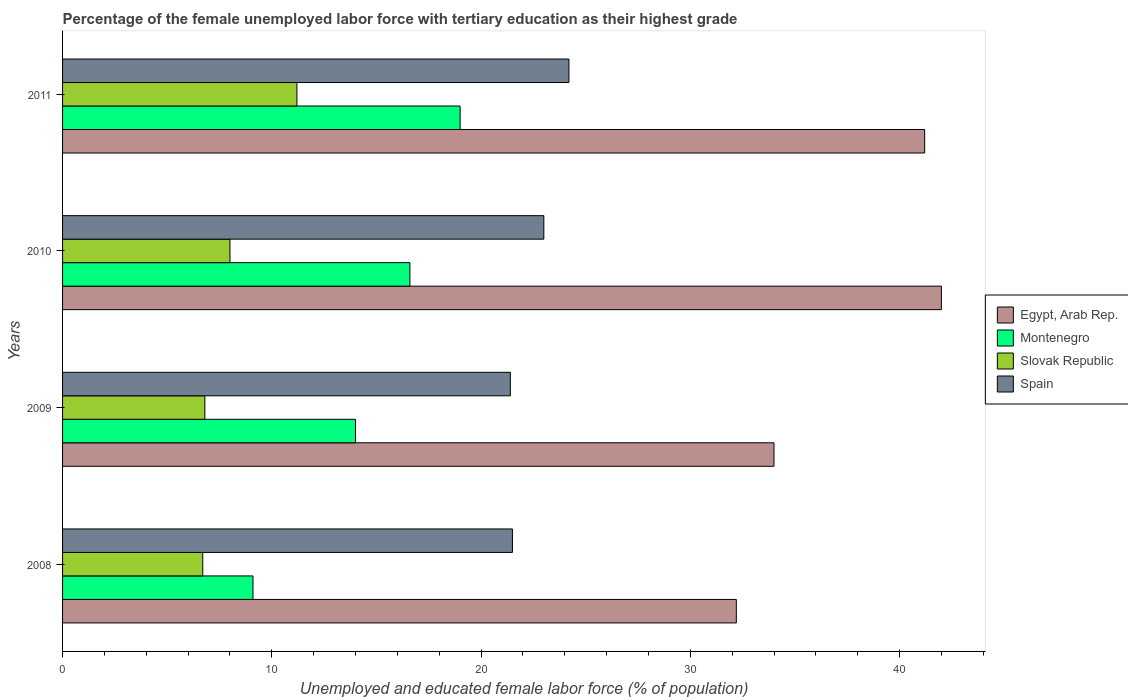How many different coloured bars are there?
Provide a short and direct response. 4. How many groups of bars are there?
Ensure brevity in your answer.  4. Are the number of bars per tick equal to the number of legend labels?
Keep it short and to the point. Yes. Are the number of bars on each tick of the Y-axis equal?
Provide a succinct answer. Yes. How many bars are there on the 3rd tick from the top?
Make the answer very short. 4. What is the label of the 2nd group of bars from the top?
Provide a short and direct response. 2010. What is the percentage of the unemployed female labor force with tertiary education in Egypt, Arab Rep. in 2010?
Offer a very short reply. 42. Across all years, what is the maximum percentage of the unemployed female labor force with tertiary education in Montenegro?
Make the answer very short. 19. Across all years, what is the minimum percentage of the unemployed female labor force with tertiary education in Slovak Republic?
Your response must be concise. 6.7. In which year was the percentage of the unemployed female labor force with tertiary education in Slovak Republic minimum?
Give a very brief answer. 2008. What is the total percentage of the unemployed female labor force with tertiary education in Egypt, Arab Rep. in the graph?
Give a very brief answer. 149.4. What is the difference between the percentage of the unemployed female labor force with tertiary education in Slovak Republic in 2008 and that in 2011?
Provide a short and direct response. -4.5. What is the difference between the percentage of the unemployed female labor force with tertiary education in Spain in 2011 and the percentage of the unemployed female labor force with tertiary education in Slovak Republic in 2008?
Ensure brevity in your answer.  17.5. What is the average percentage of the unemployed female labor force with tertiary education in Slovak Republic per year?
Your answer should be very brief. 8.17. In the year 2011, what is the difference between the percentage of the unemployed female labor force with tertiary education in Egypt, Arab Rep. and percentage of the unemployed female labor force with tertiary education in Slovak Republic?
Keep it short and to the point. 30. What is the ratio of the percentage of the unemployed female labor force with tertiary education in Spain in 2010 to that in 2011?
Offer a very short reply. 0.95. Is the percentage of the unemployed female labor force with tertiary education in Spain in 2009 less than that in 2011?
Offer a terse response. Yes. Is the difference between the percentage of the unemployed female labor force with tertiary education in Egypt, Arab Rep. in 2008 and 2009 greater than the difference between the percentage of the unemployed female labor force with tertiary education in Slovak Republic in 2008 and 2009?
Your answer should be very brief. No. What is the difference between the highest and the second highest percentage of the unemployed female labor force with tertiary education in Montenegro?
Make the answer very short. 2.4. What is the difference between the highest and the lowest percentage of the unemployed female labor force with tertiary education in Slovak Republic?
Your response must be concise. 4.5. Is it the case that in every year, the sum of the percentage of the unemployed female labor force with tertiary education in Spain and percentage of the unemployed female labor force with tertiary education in Slovak Republic is greater than the sum of percentage of the unemployed female labor force with tertiary education in Montenegro and percentage of the unemployed female labor force with tertiary education in Egypt, Arab Rep.?
Ensure brevity in your answer.  Yes. What does the 3rd bar from the top in 2009 represents?
Keep it short and to the point. Montenegro. What does the 2nd bar from the bottom in 2010 represents?
Keep it short and to the point. Montenegro. Are all the bars in the graph horizontal?
Ensure brevity in your answer.  Yes. Does the graph contain any zero values?
Your answer should be very brief. No. How are the legend labels stacked?
Make the answer very short. Vertical. What is the title of the graph?
Offer a terse response. Percentage of the female unemployed labor force with tertiary education as their highest grade. What is the label or title of the X-axis?
Provide a short and direct response. Unemployed and educated female labor force (% of population). What is the label or title of the Y-axis?
Give a very brief answer. Years. What is the Unemployed and educated female labor force (% of population) in Egypt, Arab Rep. in 2008?
Your answer should be compact. 32.2. What is the Unemployed and educated female labor force (% of population) in Montenegro in 2008?
Offer a terse response. 9.1. What is the Unemployed and educated female labor force (% of population) of Slovak Republic in 2008?
Give a very brief answer. 6.7. What is the Unemployed and educated female labor force (% of population) in Spain in 2008?
Ensure brevity in your answer.  21.5. What is the Unemployed and educated female labor force (% of population) of Egypt, Arab Rep. in 2009?
Give a very brief answer. 34. What is the Unemployed and educated female labor force (% of population) in Montenegro in 2009?
Offer a very short reply. 14. What is the Unemployed and educated female labor force (% of population) of Slovak Republic in 2009?
Ensure brevity in your answer.  6.8. What is the Unemployed and educated female labor force (% of population) of Spain in 2009?
Offer a terse response. 21.4. What is the Unemployed and educated female labor force (% of population) of Montenegro in 2010?
Your response must be concise. 16.6. What is the Unemployed and educated female labor force (% of population) of Slovak Republic in 2010?
Your answer should be very brief. 8. What is the Unemployed and educated female labor force (% of population) in Spain in 2010?
Keep it short and to the point. 23. What is the Unemployed and educated female labor force (% of population) in Egypt, Arab Rep. in 2011?
Offer a very short reply. 41.2. What is the Unemployed and educated female labor force (% of population) in Slovak Republic in 2011?
Provide a succinct answer. 11.2. What is the Unemployed and educated female labor force (% of population) in Spain in 2011?
Provide a short and direct response. 24.2. Across all years, what is the maximum Unemployed and educated female labor force (% of population) in Montenegro?
Provide a short and direct response. 19. Across all years, what is the maximum Unemployed and educated female labor force (% of population) in Slovak Republic?
Provide a succinct answer. 11.2. Across all years, what is the maximum Unemployed and educated female labor force (% of population) in Spain?
Make the answer very short. 24.2. Across all years, what is the minimum Unemployed and educated female labor force (% of population) of Egypt, Arab Rep.?
Offer a very short reply. 32.2. Across all years, what is the minimum Unemployed and educated female labor force (% of population) of Montenegro?
Offer a very short reply. 9.1. Across all years, what is the minimum Unemployed and educated female labor force (% of population) in Slovak Republic?
Make the answer very short. 6.7. Across all years, what is the minimum Unemployed and educated female labor force (% of population) of Spain?
Your answer should be compact. 21.4. What is the total Unemployed and educated female labor force (% of population) of Egypt, Arab Rep. in the graph?
Keep it short and to the point. 149.4. What is the total Unemployed and educated female labor force (% of population) of Montenegro in the graph?
Your response must be concise. 58.7. What is the total Unemployed and educated female labor force (% of population) of Slovak Republic in the graph?
Offer a terse response. 32.7. What is the total Unemployed and educated female labor force (% of population) in Spain in the graph?
Keep it short and to the point. 90.1. What is the difference between the Unemployed and educated female labor force (% of population) of Egypt, Arab Rep. in 2008 and that in 2009?
Your response must be concise. -1.8. What is the difference between the Unemployed and educated female labor force (% of population) in Spain in 2008 and that in 2009?
Provide a succinct answer. 0.1. What is the difference between the Unemployed and educated female labor force (% of population) of Egypt, Arab Rep. in 2008 and that in 2010?
Offer a terse response. -9.8. What is the difference between the Unemployed and educated female labor force (% of population) in Montenegro in 2008 and that in 2010?
Your answer should be very brief. -7.5. What is the difference between the Unemployed and educated female labor force (% of population) of Spain in 2008 and that in 2010?
Your answer should be compact. -1.5. What is the difference between the Unemployed and educated female labor force (% of population) in Montenegro in 2008 and that in 2011?
Ensure brevity in your answer.  -9.9. What is the difference between the Unemployed and educated female labor force (% of population) in Spain in 2008 and that in 2011?
Your response must be concise. -2.7. What is the difference between the Unemployed and educated female labor force (% of population) in Egypt, Arab Rep. in 2009 and that in 2010?
Give a very brief answer. -8. What is the difference between the Unemployed and educated female labor force (% of population) in Slovak Republic in 2009 and that in 2010?
Your answer should be very brief. -1.2. What is the difference between the Unemployed and educated female labor force (% of population) of Egypt, Arab Rep. in 2009 and that in 2011?
Your response must be concise. -7.2. What is the difference between the Unemployed and educated female labor force (% of population) of Slovak Republic in 2009 and that in 2011?
Ensure brevity in your answer.  -4.4. What is the difference between the Unemployed and educated female labor force (% of population) in Egypt, Arab Rep. in 2010 and that in 2011?
Make the answer very short. 0.8. What is the difference between the Unemployed and educated female labor force (% of population) in Montenegro in 2010 and that in 2011?
Offer a very short reply. -2.4. What is the difference between the Unemployed and educated female labor force (% of population) in Slovak Republic in 2010 and that in 2011?
Your answer should be compact. -3.2. What is the difference between the Unemployed and educated female labor force (% of population) in Egypt, Arab Rep. in 2008 and the Unemployed and educated female labor force (% of population) in Montenegro in 2009?
Offer a terse response. 18.2. What is the difference between the Unemployed and educated female labor force (% of population) in Egypt, Arab Rep. in 2008 and the Unemployed and educated female labor force (% of population) in Slovak Republic in 2009?
Your answer should be compact. 25.4. What is the difference between the Unemployed and educated female labor force (% of population) of Slovak Republic in 2008 and the Unemployed and educated female labor force (% of population) of Spain in 2009?
Your response must be concise. -14.7. What is the difference between the Unemployed and educated female labor force (% of population) of Egypt, Arab Rep. in 2008 and the Unemployed and educated female labor force (% of population) of Montenegro in 2010?
Make the answer very short. 15.6. What is the difference between the Unemployed and educated female labor force (% of population) of Egypt, Arab Rep. in 2008 and the Unemployed and educated female labor force (% of population) of Slovak Republic in 2010?
Your answer should be very brief. 24.2. What is the difference between the Unemployed and educated female labor force (% of population) in Egypt, Arab Rep. in 2008 and the Unemployed and educated female labor force (% of population) in Spain in 2010?
Provide a short and direct response. 9.2. What is the difference between the Unemployed and educated female labor force (% of population) of Montenegro in 2008 and the Unemployed and educated female labor force (% of population) of Slovak Republic in 2010?
Your answer should be very brief. 1.1. What is the difference between the Unemployed and educated female labor force (% of population) in Montenegro in 2008 and the Unemployed and educated female labor force (% of population) in Spain in 2010?
Offer a terse response. -13.9. What is the difference between the Unemployed and educated female labor force (% of population) of Slovak Republic in 2008 and the Unemployed and educated female labor force (% of population) of Spain in 2010?
Offer a very short reply. -16.3. What is the difference between the Unemployed and educated female labor force (% of population) in Montenegro in 2008 and the Unemployed and educated female labor force (% of population) in Slovak Republic in 2011?
Keep it short and to the point. -2.1. What is the difference between the Unemployed and educated female labor force (% of population) of Montenegro in 2008 and the Unemployed and educated female labor force (% of population) of Spain in 2011?
Offer a terse response. -15.1. What is the difference between the Unemployed and educated female labor force (% of population) in Slovak Republic in 2008 and the Unemployed and educated female labor force (% of population) in Spain in 2011?
Provide a succinct answer. -17.5. What is the difference between the Unemployed and educated female labor force (% of population) of Egypt, Arab Rep. in 2009 and the Unemployed and educated female labor force (% of population) of Slovak Republic in 2010?
Ensure brevity in your answer.  26. What is the difference between the Unemployed and educated female labor force (% of population) in Egypt, Arab Rep. in 2009 and the Unemployed and educated female labor force (% of population) in Spain in 2010?
Keep it short and to the point. 11. What is the difference between the Unemployed and educated female labor force (% of population) in Montenegro in 2009 and the Unemployed and educated female labor force (% of population) in Slovak Republic in 2010?
Your answer should be compact. 6. What is the difference between the Unemployed and educated female labor force (% of population) of Montenegro in 2009 and the Unemployed and educated female labor force (% of population) of Spain in 2010?
Keep it short and to the point. -9. What is the difference between the Unemployed and educated female labor force (% of population) in Slovak Republic in 2009 and the Unemployed and educated female labor force (% of population) in Spain in 2010?
Give a very brief answer. -16.2. What is the difference between the Unemployed and educated female labor force (% of population) of Egypt, Arab Rep. in 2009 and the Unemployed and educated female labor force (% of population) of Montenegro in 2011?
Your response must be concise. 15. What is the difference between the Unemployed and educated female labor force (% of population) of Egypt, Arab Rep. in 2009 and the Unemployed and educated female labor force (% of population) of Slovak Republic in 2011?
Your answer should be compact. 22.8. What is the difference between the Unemployed and educated female labor force (% of population) of Egypt, Arab Rep. in 2009 and the Unemployed and educated female labor force (% of population) of Spain in 2011?
Keep it short and to the point. 9.8. What is the difference between the Unemployed and educated female labor force (% of population) of Montenegro in 2009 and the Unemployed and educated female labor force (% of population) of Slovak Republic in 2011?
Give a very brief answer. 2.8. What is the difference between the Unemployed and educated female labor force (% of population) of Montenegro in 2009 and the Unemployed and educated female labor force (% of population) of Spain in 2011?
Offer a terse response. -10.2. What is the difference between the Unemployed and educated female labor force (% of population) of Slovak Republic in 2009 and the Unemployed and educated female labor force (% of population) of Spain in 2011?
Your response must be concise. -17.4. What is the difference between the Unemployed and educated female labor force (% of population) of Egypt, Arab Rep. in 2010 and the Unemployed and educated female labor force (% of population) of Montenegro in 2011?
Give a very brief answer. 23. What is the difference between the Unemployed and educated female labor force (% of population) of Egypt, Arab Rep. in 2010 and the Unemployed and educated female labor force (% of population) of Slovak Republic in 2011?
Your response must be concise. 30.8. What is the difference between the Unemployed and educated female labor force (% of population) in Egypt, Arab Rep. in 2010 and the Unemployed and educated female labor force (% of population) in Spain in 2011?
Offer a terse response. 17.8. What is the difference between the Unemployed and educated female labor force (% of population) of Montenegro in 2010 and the Unemployed and educated female labor force (% of population) of Slovak Republic in 2011?
Make the answer very short. 5.4. What is the difference between the Unemployed and educated female labor force (% of population) in Montenegro in 2010 and the Unemployed and educated female labor force (% of population) in Spain in 2011?
Your answer should be compact. -7.6. What is the difference between the Unemployed and educated female labor force (% of population) in Slovak Republic in 2010 and the Unemployed and educated female labor force (% of population) in Spain in 2011?
Provide a short and direct response. -16.2. What is the average Unemployed and educated female labor force (% of population) in Egypt, Arab Rep. per year?
Offer a very short reply. 37.35. What is the average Unemployed and educated female labor force (% of population) in Montenegro per year?
Keep it short and to the point. 14.68. What is the average Unemployed and educated female labor force (% of population) in Slovak Republic per year?
Provide a short and direct response. 8.18. What is the average Unemployed and educated female labor force (% of population) of Spain per year?
Offer a terse response. 22.52. In the year 2008, what is the difference between the Unemployed and educated female labor force (% of population) of Egypt, Arab Rep. and Unemployed and educated female labor force (% of population) of Montenegro?
Make the answer very short. 23.1. In the year 2008, what is the difference between the Unemployed and educated female labor force (% of population) in Egypt, Arab Rep. and Unemployed and educated female labor force (% of population) in Slovak Republic?
Provide a short and direct response. 25.5. In the year 2008, what is the difference between the Unemployed and educated female labor force (% of population) of Egypt, Arab Rep. and Unemployed and educated female labor force (% of population) of Spain?
Your answer should be compact. 10.7. In the year 2008, what is the difference between the Unemployed and educated female labor force (% of population) in Montenegro and Unemployed and educated female labor force (% of population) in Slovak Republic?
Your answer should be compact. 2.4. In the year 2008, what is the difference between the Unemployed and educated female labor force (% of population) of Slovak Republic and Unemployed and educated female labor force (% of population) of Spain?
Your answer should be compact. -14.8. In the year 2009, what is the difference between the Unemployed and educated female labor force (% of population) in Egypt, Arab Rep. and Unemployed and educated female labor force (% of population) in Montenegro?
Give a very brief answer. 20. In the year 2009, what is the difference between the Unemployed and educated female labor force (% of population) of Egypt, Arab Rep. and Unemployed and educated female labor force (% of population) of Slovak Republic?
Ensure brevity in your answer.  27.2. In the year 2009, what is the difference between the Unemployed and educated female labor force (% of population) of Montenegro and Unemployed and educated female labor force (% of population) of Spain?
Give a very brief answer. -7.4. In the year 2009, what is the difference between the Unemployed and educated female labor force (% of population) of Slovak Republic and Unemployed and educated female labor force (% of population) of Spain?
Provide a short and direct response. -14.6. In the year 2010, what is the difference between the Unemployed and educated female labor force (% of population) of Egypt, Arab Rep. and Unemployed and educated female labor force (% of population) of Montenegro?
Give a very brief answer. 25.4. In the year 2010, what is the difference between the Unemployed and educated female labor force (% of population) in Egypt, Arab Rep. and Unemployed and educated female labor force (% of population) in Spain?
Ensure brevity in your answer.  19. In the year 2010, what is the difference between the Unemployed and educated female labor force (% of population) in Montenegro and Unemployed and educated female labor force (% of population) in Spain?
Offer a terse response. -6.4. In the year 2011, what is the difference between the Unemployed and educated female labor force (% of population) of Egypt, Arab Rep. and Unemployed and educated female labor force (% of population) of Montenegro?
Provide a succinct answer. 22.2. In the year 2011, what is the difference between the Unemployed and educated female labor force (% of population) of Egypt, Arab Rep. and Unemployed and educated female labor force (% of population) of Slovak Republic?
Your answer should be very brief. 30. In the year 2011, what is the difference between the Unemployed and educated female labor force (% of population) in Egypt, Arab Rep. and Unemployed and educated female labor force (% of population) in Spain?
Offer a terse response. 17. In the year 2011, what is the difference between the Unemployed and educated female labor force (% of population) in Montenegro and Unemployed and educated female labor force (% of population) in Slovak Republic?
Make the answer very short. 7.8. In the year 2011, what is the difference between the Unemployed and educated female labor force (% of population) of Montenegro and Unemployed and educated female labor force (% of population) of Spain?
Offer a terse response. -5.2. In the year 2011, what is the difference between the Unemployed and educated female labor force (% of population) of Slovak Republic and Unemployed and educated female labor force (% of population) of Spain?
Your response must be concise. -13. What is the ratio of the Unemployed and educated female labor force (% of population) of Egypt, Arab Rep. in 2008 to that in 2009?
Keep it short and to the point. 0.95. What is the ratio of the Unemployed and educated female labor force (% of population) in Montenegro in 2008 to that in 2009?
Your answer should be very brief. 0.65. What is the ratio of the Unemployed and educated female labor force (% of population) of Slovak Republic in 2008 to that in 2009?
Ensure brevity in your answer.  0.99. What is the ratio of the Unemployed and educated female labor force (% of population) of Spain in 2008 to that in 2009?
Ensure brevity in your answer.  1. What is the ratio of the Unemployed and educated female labor force (% of population) of Egypt, Arab Rep. in 2008 to that in 2010?
Offer a very short reply. 0.77. What is the ratio of the Unemployed and educated female labor force (% of population) of Montenegro in 2008 to that in 2010?
Provide a short and direct response. 0.55. What is the ratio of the Unemployed and educated female labor force (% of population) of Slovak Republic in 2008 to that in 2010?
Keep it short and to the point. 0.84. What is the ratio of the Unemployed and educated female labor force (% of population) of Spain in 2008 to that in 2010?
Provide a short and direct response. 0.93. What is the ratio of the Unemployed and educated female labor force (% of population) of Egypt, Arab Rep. in 2008 to that in 2011?
Make the answer very short. 0.78. What is the ratio of the Unemployed and educated female labor force (% of population) in Montenegro in 2008 to that in 2011?
Your answer should be very brief. 0.48. What is the ratio of the Unemployed and educated female labor force (% of population) of Slovak Republic in 2008 to that in 2011?
Provide a short and direct response. 0.6. What is the ratio of the Unemployed and educated female labor force (% of population) of Spain in 2008 to that in 2011?
Provide a short and direct response. 0.89. What is the ratio of the Unemployed and educated female labor force (% of population) in Egypt, Arab Rep. in 2009 to that in 2010?
Provide a short and direct response. 0.81. What is the ratio of the Unemployed and educated female labor force (% of population) in Montenegro in 2009 to that in 2010?
Your answer should be very brief. 0.84. What is the ratio of the Unemployed and educated female labor force (% of population) in Spain in 2009 to that in 2010?
Give a very brief answer. 0.93. What is the ratio of the Unemployed and educated female labor force (% of population) in Egypt, Arab Rep. in 2009 to that in 2011?
Ensure brevity in your answer.  0.83. What is the ratio of the Unemployed and educated female labor force (% of population) of Montenegro in 2009 to that in 2011?
Your response must be concise. 0.74. What is the ratio of the Unemployed and educated female labor force (% of population) in Slovak Republic in 2009 to that in 2011?
Offer a very short reply. 0.61. What is the ratio of the Unemployed and educated female labor force (% of population) of Spain in 2009 to that in 2011?
Give a very brief answer. 0.88. What is the ratio of the Unemployed and educated female labor force (% of population) of Egypt, Arab Rep. in 2010 to that in 2011?
Your answer should be very brief. 1.02. What is the ratio of the Unemployed and educated female labor force (% of population) of Montenegro in 2010 to that in 2011?
Provide a succinct answer. 0.87. What is the ratio of the Unemployed and educated female labor force (% of population) in Spain in 2010 to that in 2011?
Your answer should be very brief. 0.95. What is the difference between the highest and the second highest Unemployed and educated female labor force (% of population) in Egypt, Arab Rep.?
Offer a very short reply. 0.8. What is the difference between the highest and the lowest Unemployed and educated female labor force (% of population) of Egypt, Arab Rep.?
Provide a short and direct response. 9.8. What is the difference between the highest and the lowest Unemployed and educated female labor force (% of population) in Montenegro?
Offer a terse response. 9.9. What is the difference between the highest and the lowest Unemployed and educated female labor force (% of population) of Slovak Republic?
Ensure brevity in your answer.  4.5. 